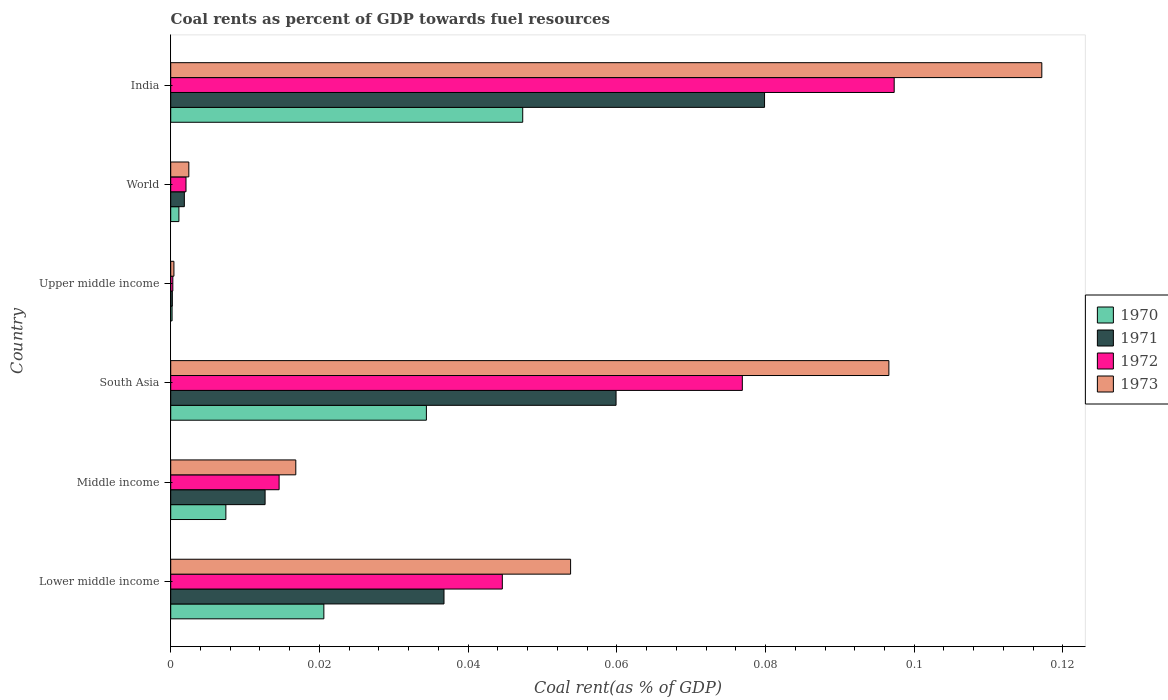How many groups of bars are there?
Make the answer very short. 6. Are the number of bars per tick equal to the number of legend labels?
Give a very brief answer. Yes. How many bars are there on the 4th tick from the bottom?
Your answer should be very brief. 4. What is the label of the 2nd group of bars from the top?
Keep it short and to the point. World. What is the coal rent in 1970 in World?
Make the answer very short. 0. Across all countries, what is the maximum coal rent in 1970?
Make the answer very short. 0.05. Across all countries, what is the minimum coal rent in 1971?
Provide a succinct answer. 0. In which country was the coal rent in 1971 maximum?
Your response must be concise. India. In which country was the coal rent in 1970 minimum?
Provide a succinct answer. Upper middle income. What is the total coal rent in 1972 in the graph?
Provide a succinct answer. 0.24. What is the difference between the coal rent in 1971 in India and that in Middle income?
Make the answer very short. 0.07. What is the difference between the coal rent in 1971 in South Asia and the coal rent in 1973 in World?
Your answer should be compact. 0.06. What is the average coal rent in 1971 per country?
Offer a terse response. 0.03. What is the difference between the coal rent in 1972 and coal rent in 1971 in World?
Ensure brevity in your answer.  0. What is the ratio of the coal rent in 1971 in Middle income to that in Upper middle income?
Offer a very short reply. 58.01. What is the difference between the highest and the second highest coal rent in 1973?
Your answer should be compact. 0.02. What is the difference between the highest and the lowest coal rent in 1973?
Provide a short and direct response. 0.12. In how many countries, is the coal rent in 1970 greater than the average coal rent in 1970 taken over all countries?
Your answer should be very brief. 3. Is the sum of the coal rent in 1972 in Lower middle income and South Asia greater than the maximum coal rent in 1973 across all countries?
Give a very brief answer. Yes. Is it the case that in every country, the sum of the coal rent in 1970 and coal rent in 1971 is greater than the sum of coal rent in 1972 and coal rent in 1973?
Offer a very short reply. No. Are all the bars in the graph horizontal?
Keep it short and to the point. Yes. How many countries are there in the graph?
Offer a terse response. 6. What is the difference between two consecutive major ticks on the X-axis?
Provide a succinct answer. 0.02. Are the values on the major ticks of X-axis written in scientific E-notation?
Provide a succinct answer. No. How many legend labels are there?
Your response must be concise. 4. How are the legend labels stacked?
Offer a very short reply. Vertical. What is the title of the graph?
Your response must be concise. Coal rents as percent of GDP towards fuel resources. Does "1967" appear as one of the legend labels in the graph?
Provide a succinct answer. No. What is the label or title of the X-axis?
Your answer should be compact. Coal rent(as % of GDP). What is the Coal rent(as % of GDP) of 1970 in Lower middle income?
Provide a succinct answer. 0.02. What is the Coal rent(as % of GDP) of 1971 in Lower middle income?
Your answer should be very brief. 0.04. What is the Coal rent(as % of GDP) in 1972 in Lower middle income?
Make the answer very short. 0.04. What is the Coal rent(as % of GDP) of 1973 in Lower middle income?
Keep it short and to the point. 0.05. What is the Coal rent(as % of GDP) of 1970 in Middle income?
Ensure brevity in your answer.  0.01. What is the Coal rent(as % of GDP) of 1971 in Middle income?
Your response must be concise. 0.01. What is the Coal rent(as % of GDP) in 1972 in Middle income?
Your response must be concise. 0.01. What is the Coal rent(as % of GDP) of 1973 in Middle income?
Your answer should be very brief. 0.02. What is the Coal rent(as % of GDP) of 1970 in South Asia?
Offer a very short reply. 0.03. What is the Coal rent(as % of GDP) in 1971 in South Asia?
Offer a very short reply. 0.06. What is the Coal rent(as % of GDP) of 1972 in South Asia?
Your answer should be very brief. 0.08. What is the Coal rent(as % of GDP) in 1973 in South Asia?
Make the answer very short. 0.1. What is the Coal rent(as % of GDP) in 1970 in Upper middle income?
Ensure brevity in your answer.  0. What is the Coal rent(as % of GDP) in 1971 in Upper middle income?
Make the answer very short. 0. What is the Coal rent(as % of GDP) in 1972 in Upper middle income?
Make the answer very short. 0. What is the Coal rent(as % of GDP) in 1973 in Upper middle income?
Your answer should be very brief. 0. What is the Coal rent(as % of GDP) of 1970 in World?
Provide a short and direct response. 0. What is the Coal rent(as % of GDP) of 1971 in World?
Your answer should be compact. 0. What is the Coal rent(as % of GDP) in 1972 in World?
Make the answer very short. 0. What is the Coal rent(as % of GDP) of 1973 in World?
Keep it short and to the point. 0. What is the Coal rent(as % of GDP) of 1970 in India?
Make the answer very short. 0.05. What is the Coal rent(as % of GDP) of 1971 in India?
Your response must be concise. 0.08. What is the Coal rent(as % of GDP) in 1972 in India?
Give a very brief answer. 0.1. What is the Coal rent(as % of GDP) of 1973 in India?
Provide a succinct answer. 0.12. Across all countries, what is the maximum Coal rent(as % of GDP) in 1970?
Make the answer very short. 0.05. Across all countries, what is the maximum Coal rent(as % of GDP) in 1971?
Your answer should be very brief. 0.08. Across all countries, what is the maximum Coal rent(as % of GDP) in 1972?
Keep it short and to the point. 0.1. Across all countries, what is the maximum Coal rent(as % of GDP) of 1973?
Ensure brevity in your answer.  0.12. Across all countries, what is the minimum Coal rent(as % of GDP) in 1970?
Provide a succinct answer. 0. Across all countries, what is the minimum Coal rent(as % of GDP) of 1971?
Your response must be concise. 0. Across all countries, what is the minimum Coal rent(as % of GDP) in 1972?
Give a very brief answer. 0. Across all countries, what is the minimum Coal rent(as % of GDP) of 1973?
Your response must be concise. 0. What is the total Coal rent(as % of GDP) in 1970 in the graph?
Offer a terse response. 0.11. What is the total Coal rent(as % of GDP) of 1971 in the graph?
Your response must be concise. 0.19. What is the total Coal rent(as % of GDP) in 1972 in the graph?
Your answer should be compact. 0.24. What is the total Coal rent(as % of GDP) of 1973 in the graph?
Make the answer very short. 0.29. What is the difference between the Coal rent(as % of GDP) of 1970 in Lower middle income and that in Middle income?
Give a very brief answer. 0.01. What is the difference between the Coal rent(as % of GDP) in 1971 in Lower middle income and that in Middle income?
Provide a succinct answer. 0.02. What is the difference between the Coal rent(as % of GDP) of 1972 in Lower middle income and that in Middle income?
Your answer should be compact. 0.03. What is the difference between the Coal rent(as % of GDP) in 1973 in Lower middle income and that in Middle income?
Provide a short and direct response. 0.04. What is the difference between the Coal rent(as % of GDP) in 1970 in Lower middle income and that in South Asia?
Provide a short and direct response. -0.01. What is the difference between the Coal rent(as % of GDP) in 1971 in Lower middle income and that in South Asia?
Keep it short and to the point. -0.02. What is the difference between the Coal rent(as % of GDP) of 1972 in Lower middle income and that in South Asia?
Your answer should be compact. -0.03. What is the difference between the Coal rent(as % of GDP) in 1973 in Lower middle income and that in South Asia?
Provide a succinct answer. -0.04. What is the difference between the Coal rent(as % of GDP) in 1970 in Lower middle income and that in Upper middle income?
Give a very brief answer. 0.02. What is the difference between the Coal rent(as % of GDP) of 1971 in Lower middle income and that in Upper middle income?
Offer a terse response. 0.04. What is the difference between the Coal rent(as % of GDP) of 1972 in Lower middle income and that in Upper middle income?
Your response must be concise. 0.04. What is the difference between the Coal rent(as % of GDP) of 1973 in Lower middle income and that in Upper middle income?
Provide a short and direct response. 0.05. What is the difference between the Coal rent(as % of GDP) in 1970 in Lower middle income and that in World?
Keep it short and to the point. 0.02. What is the difference between the Coal rent(as % of GDP) in 1971 in Lower middle income and that in World?
Ensure brevity in your answer.  0.03. What is the difference between the Coal rent(as % of GDP) of 1972 in Lower middle income and that in World?
Your answer should be compact. 0.04. What is the difference between the Coal rent(as % of GDP) of 1973 in Lower middle income and that in World?
Make the answer very short. 0.05. What is the difference between the Coal rent(as % of GDP) in 1970 in Lower middle income and that in India?
Ensure brevity in your answer.  -0.03. What is the difference between the Coal rent(as % of GDP) of 1971 in Lower middle income and that in India?
Your answer should be compact. -0.04. What is the difference between the Coal rent(as % of GDP) of 1972 in Lower middle income and that in India?
Ensure brevity in your answer.  -0.05. What is the difference between the Coal rent(as % of GDP) in 1973 in Lower middle income and that in India?
Provide a succinct answer. -0.06. What is the difference between the Coal rent(as % of GDP) of 1970 in Middle income and that in South Asia?
Your response must be concise. -0.03. What is the difference between the Coal rent(as % of GDP) of 1971 in Middle income and that in South Asia?
Ensure brevity in your answer.  -0.05. What is the difference between the Coal rent(as % of GDP) of 1972 in Middle income and that in South Asia?
Give a very brief answer. -0.06. What is the difference between the Coal rent(as % of GDP) of 1973 in Middle income and that in South Asia?
Offer a very short reply. -0.08. What is the difference between the Coal rent(as % of GDP) of 1970 in Middle income and that in Upper middle income?
Your response must be concise. 0.01. What is the difference between the Coal rent(as % of GDP) in 1971 in Middle income and that in Upper middle income?
Your answer should be compact. 0.01. What is the difference between the Coal rent(as % of GDP) in 1972 in Middle income and that in Upper middle income?
Ensure brevity in your answer.  0.01. What is the difference between the Coal rent(as % of GDP) in 1973 in Middle income and that in Upper middle income?
Your response must be concise. 0.02. What is the difference between the Coal rent(as % of GDP) of 1970 in Middle income and that in World?
Keep it short and to the point. 0.01. What is the difference between the Coal rent(as % of GDP) in 1971 in Middle income and that in World?
Ensure brevity in your answer.  0.01. What is the difference between the Coal rent(as % of GDP) in 1972 in Middle income and that in World?
Offer a terse response. 0.01. What is the difference between the Coal rent(as % of GDP) in 1973 in Middle income and that in World?
Ensure brevity in your answer.  0.01. What is the difference between the Coal rent(as % of GDP) in 1970 in Middle income and that in India?
Your answer should be compact. -0.04. What is the difference between the Coal rent(as % of GDP) of 1971 in Middle income and that in India?
Your answer should be very brief. -0.07. What is the difference between the Coal rent(as % of GDP) in 1972 in Middle income and that in India?
Give a very brief answer. -0.08. What is the difference between the Coal rent(as % of GDP) in 1973 in Middle income and that in India?
Give a very brief answer. -0.1. What is the difference between the Coal rent(as % of GDP) in 1970 in South Asia and that in Upper middle income?
Your answer should be very brief. 0.03. What is the difference between the Coal rent(as % of GDP) of 1971 in South Asia and that in Upper middle income?
Keep it short and to the point. 0.06. What is the difference between the Coal rent(as % of GDP) in 1972 in South Asia and that in Upper middle income?
Your response must be concise. 0.08. What is the difference between the Coal rent(as % of GDP) of 1973 in South Asia and that in Upper middle income?
Your response must be concise. 0.1. What is the difference between the Coal rent(as % of GDP) of 1970 in South Asia and that in World?
Provide a succinct answer. 0.03. What is the difference between the Coal rent(as % of GDP) in 1971 in South Asia and that in World?
Give a very brief answer. 0.06. What is the difference between the Coal rent(as % of GDP) of 1972 in South Asia and that in World?
Give a very brief answer. 0.07. What is the difference between the Coal rent(as % of GDP) in 1973 in South Asia and that in World?
Ensure brevity in your answer.  0.09. What is the difference between the Coal rent(as % of GDP) of 1970 in South Asia and that in India?
Offer a terse response. -0.01. What is the difference between the Coal rent(as % of GDP) of 1971 in South Asia and that in India?
Offer a very short reply. -0.02. What is the difference between the Coal rent(as % of GDP) in 1972 in South Asia and that in India?
Your response must be concise. -0.02. What is the difference between the Coal rent(as % of GDP) in 1973 in South Asia and that in India?
Ensure brevity in your answer.  -0.02. What is the difference between the Coal rent(as % of GDP) of 1970 in Upper middle income and that in World?
Offer a very short reply. -0. What is the difference between the Coal rent(as % of GDP) of 1971 in Upper middle income and that in World?
Your answer should be very brief. -0. What is the difference between the Coal rent(as % of GDP) of 1972 in Upper middle income and that in World?
Keep it short and to the point. -0. What is the difference between the Coal rent(as % of GDP) in 1973 in Upper middle income and that in World?
Offer a terse response. -0. What is the difference between the Coal rent(as % of GDP) of 1970 in Upper middle income and that in India?
Ensure brevity in your answer.  -0.05. What is the difference between the Coal rent(as % of GDP) of 1971 in Upper middle income and that in India?
Ensure brevity in your answer.  -0.08. What is the difference between the Coal rent(as % of GDP) in 1972 in Upper middle income and that in India?
Keep it short and to the point. -0.1. What is the difference between the Coal rent(as % of GDP) in 1973 in Upper middle income and that in India?
Provide a short and direct response. -0.12. What is the difference between the Coal rent(as % of GDP) in 1970 in World and that in India?
Provide a succinct answer. -0.05. What is the difference between the Coal rent(as % of GDP) in 1971 in World and that in India?
Keep it short and to the point. -0.08. What is the difference between the Coal rent(as % of GDP) of 1972 in World and that in India?
Offer a very short reply. -0.1. What is the difference between the Coal rent(as % of GDP) of 1973 in World and that in India?
Offer a terse response. -0.11. What is the difference between the Coal rent(as % of GDP) of 1970 in Lower middle income and the Coal rent(as % of GDP) of 1971 in Middle income?
Provide a succinct answer. 0.01. What is the difference between the Coal rent(as % of GDP) in 1970 in Lower middle income and the Coal rent(as % of GDP) in 1972 in Middle income?
Ensure brevity in your answer.  0.01. What is the difference between the Coal rent(as % of GDP) of 1970 in Lower middle income and the Coal rent(as % of GDP) of 1973 in Middle income?
Offer a terse response. 0. What is the difference between the Coal rent(as % of GDP) in 1971 in Lower middle income and the Coal rent(as % of GDP) in 1972 in Middle income?
Ensure brevity in your answer.  0.02. What is the difference between the Coal rent(as % of GDP) in 1971 in Lower middle income and the Coal rent(as % of GDP) in 1973 in Middle income?
Your response must be concise. 0.02. What is the difference between the Coal rent(as % of GDP) in 1972 in Lower middle income and the Coal rent(as % of GDP) in 1973 in Middle income?
Your response must be concise. 0.03. What is the difference between the Coal rent(as % of GDP) in 1970 in Lower middle income and the Coal rent(as % of GDP) in 1971 in South Asia?
Ensure brevity in your answer.  -0.04. What is the difference between the Coal rent(as % of GDP) of 1970 in Lower middle income and the Coal rent(as % of GDP) of 1972 in South Asia?
Provide a short and direct response. -0.06. What is the difference between the Coal rent(as % of GDP) in 1970 in Lower middle income and the Coal rent(as % of GDP) in 1973 in South Asia?
Keep it short and to the point. -0.08. What is the difference between the Coal rent(as % of GDP) of 1971 in Lower middle income and the Coal rent(as % of GDP) of 1972 in South Asia?
Your response must be concise. -0.04. What is the difference between the Coal rent(as % of GDP) in 1971 in Lower middle income and the Coal rent(as % of GDP) in 1973 in South Asia?
Offer a very short reply. -0.06. What is the difference between the Coal rent(as % of GDP) in 1972 in Lower middle income and the Coal rent(as % of GDP) in 1973 in South Asia?
Your answer should be compact. -0.05. What is the difference between the Coal rent(as % of GDP) in 1970 in Lower middle income and the Coal rent(as % of GDP) in 1971 in Upper middle income?
Give a very brief answer. 0.02. What is the difference between the Coal rent(as % of GDP) in 1970 in Lower middle income and the Coal rent(as % of GDP) in 1972 in Upper middle income?
Provide a succinct answer. 0.02. What is the difference between the Coal rent(as % of GDP) in 1970 in Lower middle income and the Coal rent(as % of GDP) in 1973 in Upper middle income?
Provide a short and direct response. 0.02. What is the difference between the Coal rent(as % of GDP) in 1971 in Lower middle income and the Coal rent(as % of GDP) in 1972 in Upper middle income?
Offer a terse response. 0.04. What is the difference between the Coal rent(as % of GDP) in 1971 in Lower middle income and the Coal rent(as % of GDP) in 1973 in Upper middle income?
Your answer should be very brief. 0.04. What is the difference between the Coal rent(as % of GDP) in 1972 in Lower middle income and the Coal rent(as % of GDP) in 1973 in Upper middle income?
Give a very brief answer. 0.04. What is the difference between the Coal rent(as % of GDP) in 1970 in Lower middle income and the Coal rent(as % of GDP) in 1971 in World?
Keep it short and to the point. 0.02. What is the difference between the Coal rent(as % of GDP) in 1970 in Lower middle income and the Coal rent(as % of GDP) in 1972 in World?
Offer a very short reply. 0.02. What is the difference between the Coal rent(as % of GDP) in 1970 in Lower middle income and the Coal rent(as % of GDP) in 1973 in World?
Provide a short and direct response. 0.02. What is the difference between the Coal rent(as % of GDP) of 1971 in Lower middle income and the Coal rent(as % of GDP) of 1972 in World?
Offer a terse response. 0.03. What is the difference between the Coal rent(as % of GDP) in 1971 in Lower middle income and the Coal rent(as % of GDP) in 1973 in World?
Make the answer very short. 0.03. What is the difference between the Coal rent(as % of GDP) of 1972 in Lower middle income and the Coal rent(as % of GDP) of 1973 in World?
Your answer should be compact. 0.04. What is the difference between the Coal rent(as % of GDP) in 1970 in Lower middle income and the Coal rent(as % of GDP) in 1971 in India?
Your answer should be compact. -0.06. What is the difference between the Coal rent(as % of GDP) of 1970 in Lower middle income and the Coal rent(as % of GDP) of 1972 in India?
Offer a terse response. -0.08. What is the difference between the Coal rent(as % of GDP) in 1970 in Lower middle income and the Coal rent(as % of GDP) in 1973 in India?
Your response must be concise. -0.1. What is the difference between the Coal rent(as % of GDP) of 1971 in Lower middle income and the Coal rent(as % of GDP) of 1972 in India?
Provide a short and direct response. -0.06. What is the difference between the Coal rent(as % of GDP) of 1971 in Lower middle income and the Coal rent(as % of GDP) of 1973 in India?
Your answer should be very brief. -0.08. What is the difference between the Coal rent(as % of GDP) of 1972 in Lower middle income and the Coal rent(as % of GDP) of 1973 in India?
Provide a succinct answer. -0.07. What is the difference between the Coal rent(as % of GDP) of 1970 in Middle income and the Coal rent(as % of GDP) of 1971 in South Asia?
Give a very brief answer. -0.05. What is the difference between the Coal rent(as % of GDP) in 1970 in Middle income and the Coal rent(as % of GDP) in 1972 in South Asia?
Your response must be concise. -0.07. What is the difference between the Coal rent(as % of GDP) of 1970 in Middle income and the Coal rent(as % of GDP) of 1973 in South Asia?
Make the answer very short. -0.09. What is the difference between the Coal rent(as % of GDP) in 1971 in Middle income and the Coal rent(as % of GDP) in 1972 in South Asia?
Give a very brief answer. -0.06. What is the difference between the Coal rent(as % of GDP) of 1971 in Middle income and the Coal rent(as % of GDP) of 1973 in South Asia?
Ensure brevity in your answer.  -0.08. What is the difference between the Coal rent(as % of GDP) of 1972 in Middle income and the Coal rent(as % of GDP) of 1973 in South Asia?
Your answer should be compact. -0.08. What is the difference between the Coal rent(as % of GDP) in 1970 in Middle income and the Coal rent(as % of GDP) in 1971 in Upper middle income?
Your answer should be compact. 0.01. What is the difference between the Coal rent(as % of GDP) in 1970 in Middle income and the Coal rent(as % of GDP) in 1972 in Upper middle income?
Keep it short and to the point. 0.01. What is the difference between the Coal rent(as % of GDP) of 1970 in Middle income and the Coal rent(as % of GDP) of 1973 in Upper middle income?
Offer a very short reply. 0.01. What is the difference between the Coal rent(as % of GDP) in 1971 in Middle income and the Coal rent(as % of GDP) in 1972 in Upper middle income?
Keep it short and to the point. 0.01. What is the difference between the Coal rent(as % of GDP) of 1971 in Middle income and the Coal rent(as % of GDP) of 1973 in Upper middle income?
Provide a short and direct response. 0.01. What is the difference between the Coal rent(as % of GDP) of 1972 in Middle income and the Coal rent(as % of GDP) of 1973 in Upper middle income?
Ensure brevity in your answer.  0.01. What is the difference between the Coal rent(as % of GDP) in 1970 in Middle income and the Coal rent(as % of GDP) in 1971 in World?
Give a very brief answer. 0.01. What is the difference between the Coal rent(as % of GDP) in 1970 in Middle income and the Coal rent(as % of GDP) in 1972 in World?
Your answer should be compact. 0.01. What is the difference between the Coal rent(as % of GDP) in 1970 in Middle income and the Coal rent(as % of GDP) in 1973 in World?
Give a very brief answer. 0.01. What is the difference between the Coal rent(as % of GDP) of 1971 in Middle income and the Coal rent(as % of GDP) of 1972 in World?
Your answer should be compact. 0.01. What is the difference between the Coal rent(as % of GDP) in 1971 in Middle income and the Coal rent(as % of GDP) in 1973 in World?
Offer a very short reply. 0.01. What is the difference between the Coal rent(as % of GDP) of 1972 in Middle income and the Coal rent(as % of GDP) of 1973 in World?
Make the answer very short. 0.01. What is the difference between the Coal rent(as % of GDP) of 1970 in Middle income and the Coal rent(as % of GDP) of 1971 in India?
Provide a succinct answer. -0.07. What is the difference between the Coal rent(as % of GDP) of 1970 in Middle income and the Coal rent(as % of GDP) of 1972 in India?
Ensure brevity in your answer.  -0.09. What is the difference between the Coal rent(as % of GDP) in 1970 in Middle income and the Coal rent(as % of GDP) in 1973 in India?
Offer a very short reply. -0.11. What is the difference between the Coal rent(as % of GDP) in 1971 in Middle income and the Coal rent(as % of GDP) in 1972 in India?
Provide a succinct answer. -0.08. What is the difference between the Coal rent(as % of GDP) of 1971 in Middle income and the Coal rent(as % of GDP) of 1973 in India?
Provide a short and direct response. -0.1. What is the difference between the Coal rent(as % of GDP) in 1972 in Middle income and the Coal rent(as % of GDP) in 1973 in India?
Your answer should be very brief. -0.1. What is the difference between the Coal rent(as % of GDP) in 1970 in South Asia and the Coal rent(as % of GDP) in 1971 in Upper middle income?
Your answer should be compact. 0.03. What is the difference between the Coal rent(as % of GDP) of 1970 in South Asia and the Coal rent(as % of GDP) of 1972 in Upper middle income?
Provide a succinct answer. 0.03. What is the difference between the Coal rent(as % of GDP) of 1970 in South Asia and the Coal rent(as % of GDP) of 1973 in Upper middle income?
Give a very brief answer. 0.03. What is the difference between the Coal rent(as % of GDP) of 1971 in South Asia and the Coal rent(as % of GDP) of 1972 in Upper middle income?
Your response must be concise. 0.06. What is the difference between the Coal rent(as % of GDP) in 1971 in South Asia and the Coal rent(as % of GDP) in 1973 in Upper middle income?
Your response must be concise. 0.06. What is the difference between the Coal rent(as % of GDP) of 1972 in South Asia and the Coal rent(as % of GDP) of 1973 in Upper middle income?
Make the answer very short. 0.08. What is the difference between the Coal rent(as % of GDP) of 1970 in South Asia and the Coal rent(as % of GDP) of 1971 in World?
Offer a terse response. 0.03. What is the difference between the Coal rent(as % of GDP) in 1970 in South Asia and the Coal rent(as % of GDP) in 1972 in World?
Offer a terse response. 0.03. What is the difference between the Coal rent(as % of GDP) of 1970 in South Asia and the Coal rent(as % of GDP) of 1973 in World?
Your response must be concise. 0.03. What is the difference between the Coal rent(as % of GDP) of 1971 in South Asia and the Coal rent(as % of GDP) of 1972 in World?
Give a very brief answer. 0.06. What is the difference between the Coal rent(as % of GDP) of 1971 in South Asia and the Coal rent(as % of GDP) of 1973 in World?
Ensure brevity in your answer.  0.06. What is the difference between the Coal rent(as % of GDP) of 1972 in South Asia and the Coal rent(as % of GDP) of 1973 in World?
Offer a very short reply. 0.07. What is the difference between the Coal rent(as % of GDP) in 1970 in South Asia and the Coal rent(as % of GDP) in 1971 in India?
Ensure brevity in your answer.  -0.05. What is the difference between the Coal rent(as % of GDP) of 1970 in South Asia and the Coal rent(as % of GDP) of 1972 in India?
Ensure brevity in your answer.  -0.06. What is the difference between the Coal rent(as % of GDP) of 1970 in South Asia and the Coal rent(as % of GDP) of 1973 in India?
Make the answer very short. -0.08. What is the difference between the Coal rent(as % of GDP) in 1971 in South Asia and the Coal rent(as % of GDP) in 1972 in India?
Ensure brevity in your answer.  -0.04. What is the difference between the Coal rent(as % of GDP) of 1971 in South Asia and the Coal rent(as % of GDP) of 1973 in India?
Your answer should be very brief. -0.06. What is the difference between the Coal rent(as % of GDP) of 1972 in South Asia and the Coal rent(as % of GDP) of 1973 in India?
Make the answer very short. -0.04. What is the difference between the Coal rent(as % of GDP) of 1970 in Upper middle income and the Coal rent(as % of GDP) of 1971 in World?
Ensure brevity in your answer.  -0. What is the difference between the Coal rent(as % of GDP) of 1970 in Upper middle income and the Coal rent(as % of GDP) of 1972 in World?
Your answer should be compact. -0. What is the difference between the Coal rent(as % of GDP) of 1970 in Upper middle income and the Coal rent(as % of GDP) of 1973 in World?
Ensure brevity in your answer.  -0. What is the difference between the Coal rent(as % of GDP) in 1971 in Upper middle income and the Coal rent(as % of GDP) in 1972 in World?
Offer a terse response. -0. What is the difference between the Coal rent(as % of GDP) in 1971 in Upper middle income and the Coal rent(as % of GDP) in 1973 in World?
Provide a succinct answer. -0. What is the difference between the Coal rent(as % of GDP) of 1972 in Upper middle income and the Coal rent(as % of GDP) of 1973 in World?
Make the answer very short. -0. What is the difference between the Coal rent(as % of GDP) in 1970 in Upper middle income and the Coal rent(as % of GDP) in 1971 in India?
Keep it short and to the point. -0.08. What is the difference between the Coal rent(as % of GDP) of 1970 in Upper middle income and the Coal rent(as % of GDP) of 1972 in India?
Your response must be concise. -0.1. What is the difference between the Coal rent(as % of GDP) in 1970 in Upper middle income and the Coal rent(as % of GDP) in 1973 in India?
Offer a very short reply. -0.12. What is the difference between the Coal rent(as % of GDP) in 1971 in Upper middle income and the Coal rent(as % of GDP) in 1972 in India?
Your response must be concise. -0.1. What is the difference between the Coal rent(as % of GDP) in 1971 in Upper middle income and the Coal rent(as % of GDP) in 1973 in India?
Provide a short and direct response. -0.12. What is the difference between the Coal rent(as % of GDP) in 1972 in Upper middle income and the Coal rent(as % of GDP) in 1973 in India?
Provide a short and direct response. -0.12. What is the difference between the Coal rent(as % of GDP) in 1970 in World and the Coal rent(as % of GDP) in 1971 in India?
Give a very brief answer. -0.08. What is the difference between the Coal rent(as % of GDP) in 1970 in World and the Coal rent(as % of GDP) in 1972 in India?
Keep it short and to the point. -0.1. What is the difference between the Coal rent(as % of GDP) of 1970 in World and the Coal rent(as % of GDP) of 1973 in India?
Provide a succinct answer. -0.12. What is the difference between the Coal rent(as % of GDP) in 1971 in World and the Coal rent(as % of GDP) in 1972 in India?
Your answer should be very brief. -0.1. What is the difference between the Coal rent(as % of GDP) in 1971 in World and the Coal rent(as % of GDP) in 1973 in India?
Your answer should be very brief. -0.12. What is the difference between the Coal rent(as % of GDP) in 1972 in World and the Coal rent(as % of GDP) in 1973 in India?
Keep it short and to the point. -0.12. What is the average Coal rent(as % of GDP) in 1970 per country?
Provide a short and direct response. 0.02. What is the average Coal rent(as % of GDP) of 1971 per country?
Provide a succinct answer. 0.03. What is the average Coal rent(as % of GDP) of 1972 per country?
Make the answer very short. 0.04. What is the average Coal rent(as % of GDP) in 1973 per country?
Your answer should be very brief. 0.05. What is the difference between the Coal rent(as % of GDP) in 1970 and Coal rent(as % of GDP) in 1971 in Lower middle income?
Your response must be concise. -0.02. What is the difference between the Coal rent(as % of GDP) in 1970 and Coal rent(as % of GDP) in 1972 in Lower middle income?
Provide a succinct answer. -0.02. What is the difference between the Coal rent(as % of GDP) of 1970 and Coal rent(as % of GDP) of 1973 in Lower middle income?
Ensure brevity in your answer.  -0.03. What is the difference between the Coal rent(as % of GDP) of 1971 and Coal rent(as % of GDP) of 1972 in Lower middle income?
Keep it short and to the point. -0.01. What is the difference between the Coal rent(as % of GDP) in 1971 and Coal rent(as % of GDP) in 1973 in Lower middle income?
Provide a succinct answer. -0.02. What is the difference between the Coal rent(as % of GDP) in 1972 and Coal rent(as % of GDP) in 1973 in Lower middle income?
Your answer should be very brief. -0.01. What is the difference between the Coal rent(as % of GDP) of 1970 and Coal rent(as % of GDP) of 1971 in Middle income?
Give a very brief answer. -0.01. What is the difference between the Coal rent(as % of GDP) in 1970 and Coal rent(as % of GDP) in 1972 in Middle income?
Keep it short and to the point. -0.01. What is the difference between the Coal rent(as % of GDP) of 1970 and Coal rent(as % of GDP) of 1973 in Middle income?
Give a very brief answer. -0.01. What is the difference between the Coal rent(as % of GDP) in 1971 and Coal rent(as % of GDP) in 1972 in Middle income?
Offer a very short reply. -0. What is the difference between the Coal rent(as % of GDP) in 1971 and Coal rent(as % of GDP) in 1973 in Middle income?
Provide a short and direct response. -0. What is the difference between the Coal rent(as % of GDP) in 1972 and Coal rent(as % of GDP) in 1973 in Middle income?
Provide a succinct answer. -0. What is the difference between the Coal rent(as % of GDP) in 1970 and Coal rent(as % of GDP) in 1971 in South Asia?
Your response must be concise. -0.03. What is the difference between the Coal rent(as % of GDP) of 1970 and Coal rent(as % of GDP) of 1972 in South Asia?
Give a very brief answer. -0.04. What is the difference between the Coal rent(as % of GDP) in 1970 and Coal rent(as % of GDP) in 1973 in South Asia?
Give a very brief answer. -0.06. What is the difference between the Coal rent(as % of GDP) in 1971 and Coal rent(as % of GDP) in 1972 in South Asia?
Provide a succinct answer. -0.02. What is the difference between the Coal rent(as % of GDP) in 1971 and Coal rent(as % of GDP) in 1973 in South Asia?
Offer a very short reply. -0.04. What is the difference between the Coal rent(as % of GDP) in 1972 and Coal rent(as % of GDP) in 1973 in South Asia?
Keep it short and to the point. -0.02. What is the difference between the Coal rent(as % of GDP) in 1970 and Coal rent(as % of GDP) in 1971 in Upper middle income?
Offer a terse response. -0. What is the difference between the Coal rent(as % of GDP) in 1970 and Coal rent(as % of GDP) in 1972 in Upper middle income?
Keep it short and to the point. -0. What is the difference between the Coal rent(as % of GDP) of 1970 and Coal rent(as % of GDP) of 1973 in Upper middle income?
Give a very brief answer. -0. What is the difference between the Coal rent(as % of GDP) in 1971 and Coal rent(as % of GDP) in 1972 in Upper middle income?
Provide a succinct answer. -0. What is the difference between the Coal rent(as % of GDP) of 1971 and Coal rent(as % of GDP) of 1973 in Upper middle income?
Your answer should be compact. -0. What is the difference between the Coal rent(as % of GDP) of 1972 and Coal rent(as % of GDP) of 1973 in Upper middle income?
Make the answer very short. -0. What is the difference between the Coal rent(as % of GDP) of 1970 and Coal rent(as % of GDP) of 1971 in World?
Offer a very short reply. -0. What is the difference between the Coal rent(as % of GDP) in 1970 and Coal rent(as % of GDP) in 1972 in World?
Offer a terse response. -0. What is the difference between the Coal rent(as % of GDP) of 1970 and Coal rent(as % of GDP) of 1973 in World?
Provide a succinct answer. -0. What is the difference between the Coal rent(as % of GDP) of 1971 and Coal rent(as % of GDP) of 1972 in World?
Ensure brevity in your answer.  -0. What is the difference between the Coal rent(as % of GDP) in 1971 and Coal rent(as % of GDP) in 1973 in World?
Your answer should be very brief. -0. What is the difference between the Coal rent(as % of GDP) in 1972 and Coal rent(as % of GDP) in 1973 in World?
Your response must be concise. -0. What is the difference between the Coal rent(as % of GDP) of 1970 and Coal rent(as % of GDP) of 1971 in India?
Your answer should be compact. -0.03. What is the difference between the Coal rent(as % of GDP) in 1970 and Coal rent(as % of GDP) in 1973 in India?
Provide a succinct answer. -0.07. What is the difference between the Coal rent(as % of GDP) of 1971 and Coal rent(as % of GDP) of 1972 in India?
Keep it short and to the point. -0.02. What is the difference between the Coal rent(as % of GDP) of 1971 and Coal rent(as % of GDP) of 1973 in India?
Give a very brief answer. -0.04. What is the difference between the Coal rent(as % of GDP) of 1972 and Coal rent(as % of GDP) of 1973 in India?
Your answer should be compact. -0.02. What is the ratio of the Coal rent(as % of GDP) of 1970 in Lower middle income to that in Middle income?
Make the answer very short. 2.78. What is the ratio of the Coal rent(as % of GDP) of 1971 in Lower middle income to that in Middle income?
Ensure brevity in your answer.  2.9. What is the ratio of the Coal rent(as % of GDP) in 1972 in Lower middle income to that in Middle income?
Make the answer very short. 3.06. What is the ratio of the Coal rent(as % of GDP) in 1973 in Lower middle income to that in Middle income?
Your response must be concise. 3.2. What is the ratio of the Coal rent(as % of GDP) of 1970 in Lower middle income to that in South Asia?
Your response must be concise. 0.6. What is the ratio of the Coal rent(as % of GDP) of 1971 in Lower middle income to that in South Asia?
Make the answer very short. 0.61. What is the ratio of the Coal rent(as % of GDP) of 1972 in Lower middle income to that in South Asia?
Make the answer very short. 0.58. What is the ratio of the Coal rent(as % of GDP) in 1973 in Lower middle income to that in South Asia?
Your response must be concise. 0.56. What is the ratio of the Coal rent(as % of GDP) of 1970 in Lower middle income to that in Upper middle income?
Offer a very short reply. 112.03. What is the ratio of the Coal rent(as % of GDP) of 1971 in Lower middle income to that in Upper middle income?
Your answer should be compact. 167.98. What is the ratio of the Coal rent(as % of GDP) in 1972 in Lower middle income to that in Upper middle income?
Your response must be concise. 156.82. What is the ratio of the Coal rent(as % of GDP) of 1973 in Lower middle income to that in Upper middle income?
Give a very brief answer. 124.82. What is the ratio of the Coal rent(as % of GDP) in 1970 in Lower middle income to that in World?
Ensure brevity in your answer.  18.71. What is the ratio of the Coal rent(as % of GDP) in 1971 in Lower middle income to that in World?
Provide a short and direct response. 20.06. What is the ratio of the Coal rent(as % of GDP) in 1972 in Lower middle income to that in World?
Offer a very short reply. 21.7. What is the ratio of the Coal rent(as % of GDP) of 1973 in Lower middle income to that in World?
Make the answer very short. 22.07. What is the ratio of the Coal rent(as % of GDP) in 1970 in Lower middle income to that in India?
Provide a short and direct response. 0.44. What is the ratio of the Coal rent(as % of GDP) of 1971 in Lower middle income to that in India?
Offer a terse response. 0.46. What is the ratio of the Coal rent(as % of GDP) of 1972 in Lower middle income to that in India?
Your response must be concise. 0.46. What is the ratio of the Coal rent(as % of GDP) in 1973 in Lower middle income to that in India?
Give a very brief answer. 0.46. What is the ratio of the Coal rent(as % of GDP) of 1970 in Middle income to that in South Asia?
Offer a very short reply. 0.22. What is the ratio of the Coal rent(as % of GDP) of 1971 in Middle income to that in South Asia?
Ensure brevity in your answer.  0.21. What is the ratio of the Coal rent(as % of GDP) of 1972 in Middle income to that in South Asia?
Provide a succinct answer. 0.19. What is the ratio of the Coal rent(as % of GDP) in 1973 in Middle income to that in South Asia?
Your response must be concise. 0.17. What is the ratio of the Coal rent(as % of GDP) of 1970 in Middle income to that in Upper middle income?
Offer a terse response. 40.36. What is the ratio of the Coal rent(as % of GDP) of 1971 in Middle income to that in Upper middle income?
Make the answer very short. 58.01. What is the ratio of the Coal rent(as % of GDP) of 1972 in Middle income to that in Upper middle income?
Offer a very short reply. 51.25. What is the ratio of the Coal rent(as % of GDP) of 1973 in Middle income to that in Upper middle income?
Give a very brief answer. 39.04. What is the ratio of the Coal rent(as % of GDP) of 1970 in Middle income to that in World?
Offer a very short reply. 6.74. What is the ratio of the Coal rent(as % of GDP) of 1971 in Middle income to that in World?
Offer a very short reply. 6.93. What is the ratio of the Coal rent(as % of GDP) of 1972 in Middle income to that in World?
Your response must be concise. 7.09. What is the ratio of the Coal rent(as % of GDP) of 1973 in Middle income to that in World?
Your answer should be compact. 6.91. What is the ratio of the Coal rent(as % of GDP) in 1970 in Middle income to that in India?
Make the answer very short. 0.16. What is the ratio of the Coal rent(as % of GDP) of 1971 in Middle income to that in India?
Your response must be concise. 0.16. What is the ratio of the Coal rent(as % of GDP) in 1972 in Middle income to that in India?
Provide a succinct answer. 0.15. What is the ratio of the Coal rent(as % of GDP) of 1973 in Middle income to that in India?
Make the answer very short. 0.14. What is the ratio of the Coal rent(as % of GDP) of 1970 in South Asia to that in Upper middle income?
Your answer should be very brief. 187.05. What is the ratio of the Coal rent(as % of GDP) in 1971 in South Asia to that in Upper middle income?
Ensure brevity in your answer.  273.74. What is the ratio of the Coal rent(as % of GDP) in 1972 in South Asia to that in Upper middle income?
Your response must be concise. 270.32. What is the ratio of the Coal rent(as % of GDP) of 1973 in South Asia to that in Upper middle income?
Your response must be concise. 224.18. What is the ratio of the Coal rent(as % of GDP) of 1970 in South Asia to that in World?
Your answer should be very brief. 31.24. What is the ratio of the Coal rent(as % of GDP) of 1971 in South Asia to that in World?
Make the answer very short. 32.69. What is the ratio of the Coal rent(as % of GDP) in 1972 in South Asia to that in World?
Ensure brevity in your answer.  37.41. What is the ratio of the Coal rent(as % of GDP) of 1973 in South Asia to that in World?
Your answer should be very brief. 39.65. What is the ratio of the Coal rent(as % of GDP) in 1970 in South Asia to that in India?
Keep it short and to the point. 0.73. What is the ratio of the Coal rent(as % of GDP) in 1971 in South Asia to that in India?
Ensure brevity in your answer.  0.75. What is the ratio of the Coal rent(as % of GDP) in 1972 in South Asia to that in India?
Make the answer very short. 0.79. What is the ratio of the Coal rent(as % of GDP) of 1973 in South Asia to that in India?
Make the answer very short. 0.82. What is the ratio of the Coal rent(as % of GDP) in 1970 in Upper middle income to that in World?
Keep it short and to the point. 0.17. What is the ratio of the Coal rent(as % of GDP) of 1971 in Upper middle income to that in World?
Provide a short and direct response. 0.12. What is the ratio of the Coal rent(as % of GDP) in 1972 in Upper middle income to that in World?
Provide a succinct answer. 0.14. What is the ratio of the Coal rent(as % of GDP) of 1973 in Upper middle income to that in World?
Ensure brevity in your answer.  0.18. What is the ratio of the Coal rent(as % of GDP) of 1970 in Upper middle income to that in India?
Ensure brevity in your answer.  0. What is the ratio of the Coal rent(as % of GDP) of 1971 in Upper middle income to that in India?
Give a very brief answer. 0. What is the ratio of the Coal rent(as % of GDP) of 1972 in Upper middle income to that in India?
Give a very brief answer. 0. What is the ratio of the Coal rent(as % of GDP) in 1973 in Upper middle income to that in India?
Ensure brevity in your answer.  0. What is the ratio of the Coal rent(as % of GDP) in 1970 in World to that in India?
Your response must be concise. 0.02. What is the ratio of the Coal rent(as % of GDP) in 1971 in World to that in India?
Give a very brief answer. 0.02. What is the ratio of the Coal rent(as % of GDP) of 1972 in World to that in India?
Provide a short and direct response. 0.02. What is the ratio of the Coal rent(as % of GDP) of 1973 in World to that in India?
Provide a succinct answer. 0.02. What is the difference between the highest and the second highest Coal rent(as % of GDP) of 1970?
Give a very brief answer. 0.01. What is the difference between the highest and the second highest Coal rent(as % of GDP) in 1972?
Offer a very short reply. 0.02. What is the difference between the highest and the second highest Coal rent(as % of GDP) in 1973?
Offer a terse response. 0.02. What is the difference between the highest and the lowest Coal rent(as % of GDP) in 1970?
Provide a short and direct response. 0.05. What is the difference between the highest and the lowest Coal rent(as % of GDP) in 1971?
Your answer should be very brief. 0.08. What is the difference between the highest and the lowest Coal rent(as % of GDP) of 1972?
Offer a terse response. 0.1. What is the difference between the highest and the lowest Coal rent(as % of GDP) of 1973?
Your answer should be compact. 0.12. 